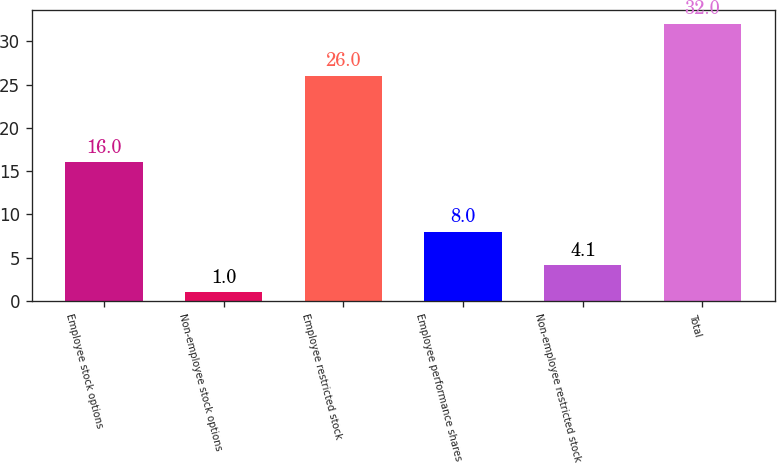Convert chart to OTSL. <chart><loc_0><loc_0><loc_500><loc_500><bar_chart><fcel>Employee stock options<fcel>Non-employee stock options<fcel>Employee restricted stock<fcel>Employee performance shares<fcel>Non-employee restricted stock<fcel>Total<nl><fcel>16<fcel>1<fcel>26<fcel>8<fcel>4.1<fcel>32<nl></chart> 